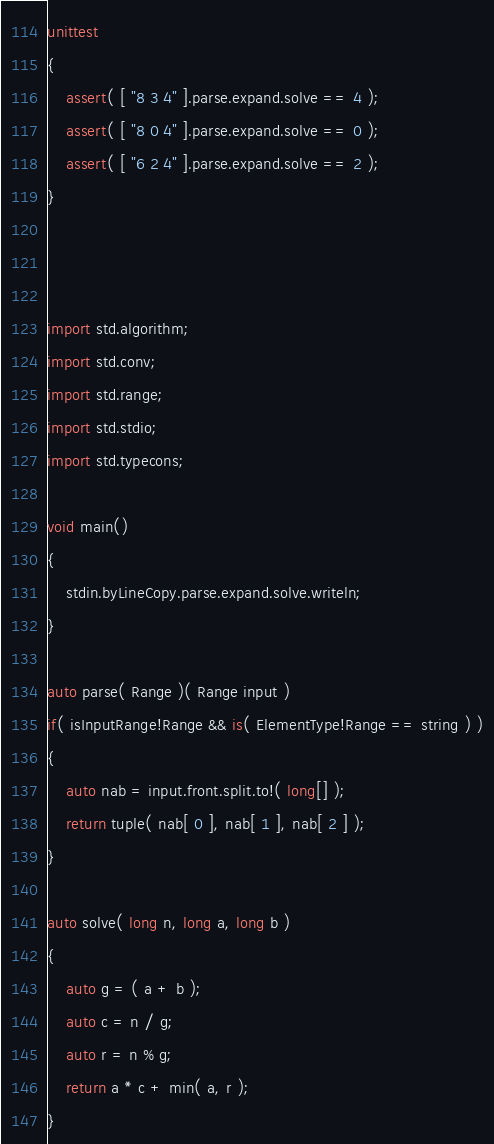<code> <loc_0><loc_0><loc_500><loc_500><_D_>unittest
{
	assert( [ "8 3 4" ].parse.expand.solve == 4 );
	assert( [ "8 0 4" ].parse.expand.solve == 0 );
	assert( [ "6 2 4" ].parse.expand.solve == 2 );
}



import std.algorithm;
import std.conv;
import std.range;
import std.stdio;
import std.typecons;

void main()
{
	stdin.byLineCopy.parse.expand.solve.writeln;
}

auto parse( Range )( Range input )
if( isInputRange!Range && is( ElementType!Range == string ) )
{
	auto nab = input.front.split.to!( long[] );
	return tuple( nab[ 0 ], nab[ 1 ], nab[ 2 ] );
}

auto solve( long n, long a, long b )
{
	auto g = ( a + b );
	auto c = n / g;
	auto r = n % g;
	return a * c + min( a, r );
}
</code> 